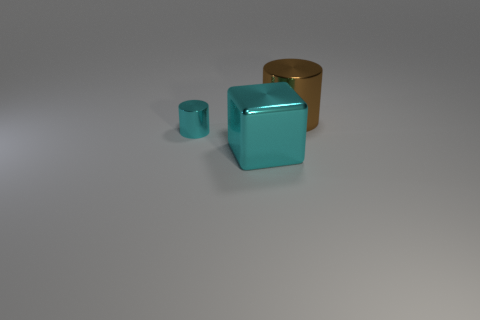Do the metallic cylinder on the left side of the large brown thing and the metallic cylinder right of the cyan metallic cylinder have the same size?
Provide a succinct answer. No. There is a block; is it the same size as the cyan metal thing that is left of the shiny cube?
Give a very brief answer. No. The cyan metallic cube has what size?
Offer a very short reply. Large. The other cylinder that is the same material as the small cylinder is what color?
Make the answer very short. Brown. How many large cyan blocks have the same material as the large brown cylinder?
Offer a very short reply. 1. What number of things are either purple blocks or cylinders that are on the left side of the shiny block?
Offer a very short reply. 1. Is the material of the cylinder in front of the large metallic cylinder the same as the large cube?
Offer a very short reply. Yes. What color is the shiny cylinder that is the same size as the cyan shiny cube?
Give a very brief answer. Brown. Are there any other cyan metallic things that have the same shape as the tiny object?
Your response must be concise. No. There is a metal thing to the right of the big metallic object that is in front of the cylinder behind the tiny cyan shiny cylinder; what color is it?
Your answer should be very brief. Brown. 